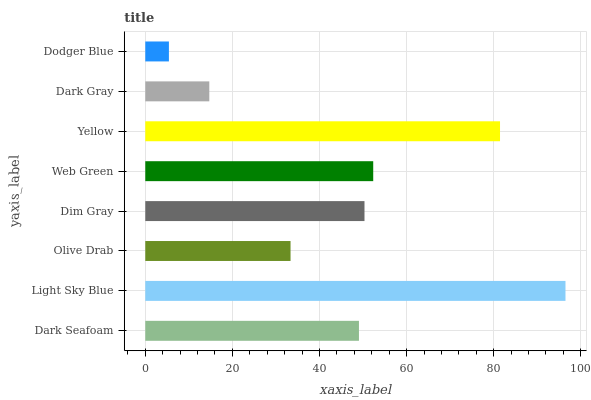Is Dodger Blue the minimum?
Answer yes or no. Yes. Is Light Sky Blue the maximum?
Answer yes or no. Yes. Is Olive Drab the minimum?
Answer yes or no. No. Is Olive Drab the maximum?
Answer yes or no. No. Is Light Sky Blue greater than Olive Drab?
Answer yes or no. Yes. Is Olive Drab less than Light Sky Blue?
Answer yes or no. Yes. Is Olive Drab greater than Light Sky Blue?
Answer yes or no. No. Is Light Sky Blue less than Olive Drab?
Answer yes or no. No. Is Dim Gray the high median?
Answer yes or no. Yes. Is Dark Seafoam the low median?
Answer yes or no. Yes. Is Web Green the high median?
Answer yes or no. No. Is Yellow the low median?
Answer yes or no. No. 